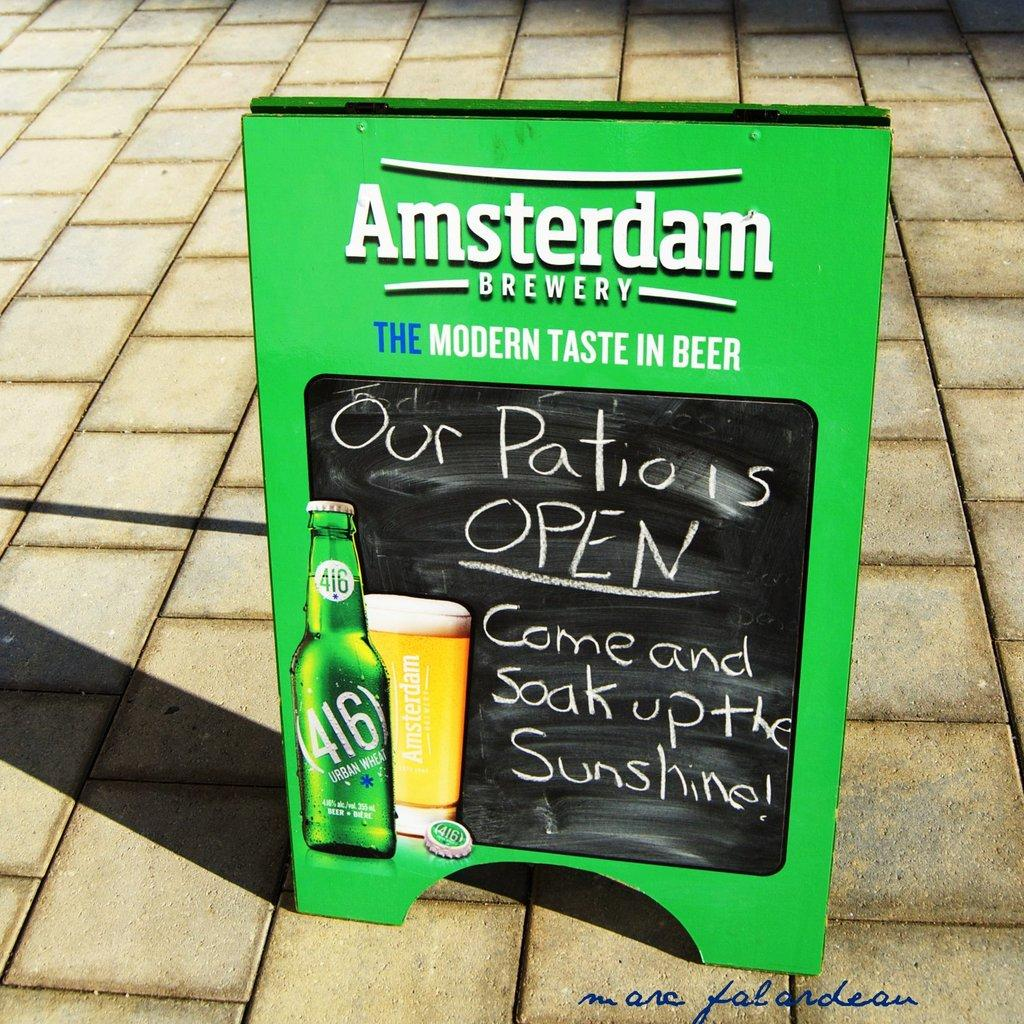What is the color of the hoarding board in the image? The hoarding board in the image is green. Where is the hoarding board located in the image? The hoarding board is on the floor. What type of throat medicine is advertised on the hoarding board? There is no throat medicine advertised on the hoarding board, as it is not mentioned in the facts provided. 